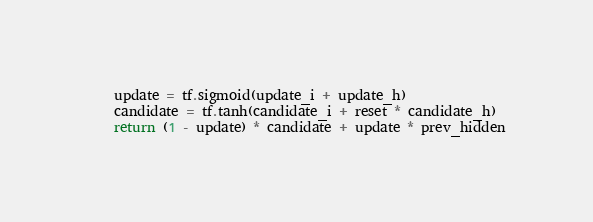Convert code to text. <code><loc_0><loc_0><loc_500><loc_500><_Python_>    update = tf.sigmoid(update_i + update_h)
    candidate = tf.tanh(candidate_i + reset * candidate_h)
    return (1 - update) * candidate + update * prev_hidden

</code> 